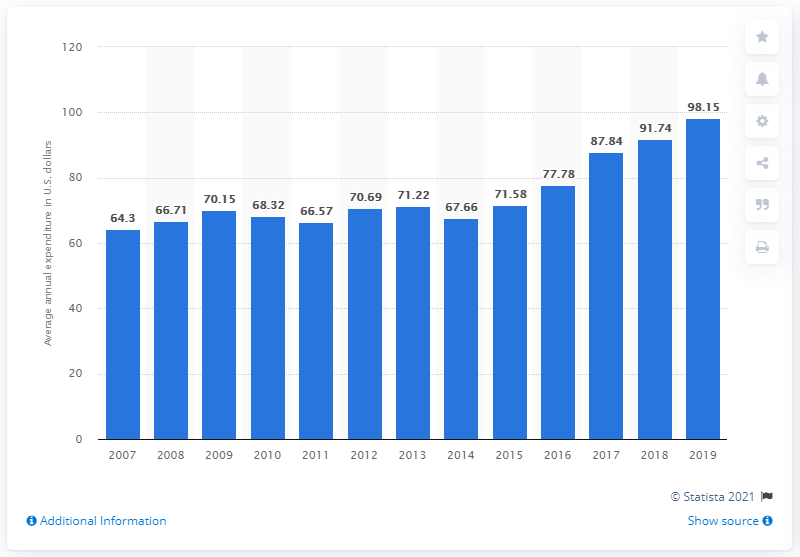Outline some significant characteristics in this image. In the United States in 2019, the average expenditure on other laundry cleaning products per consumer unit was $98.15. 